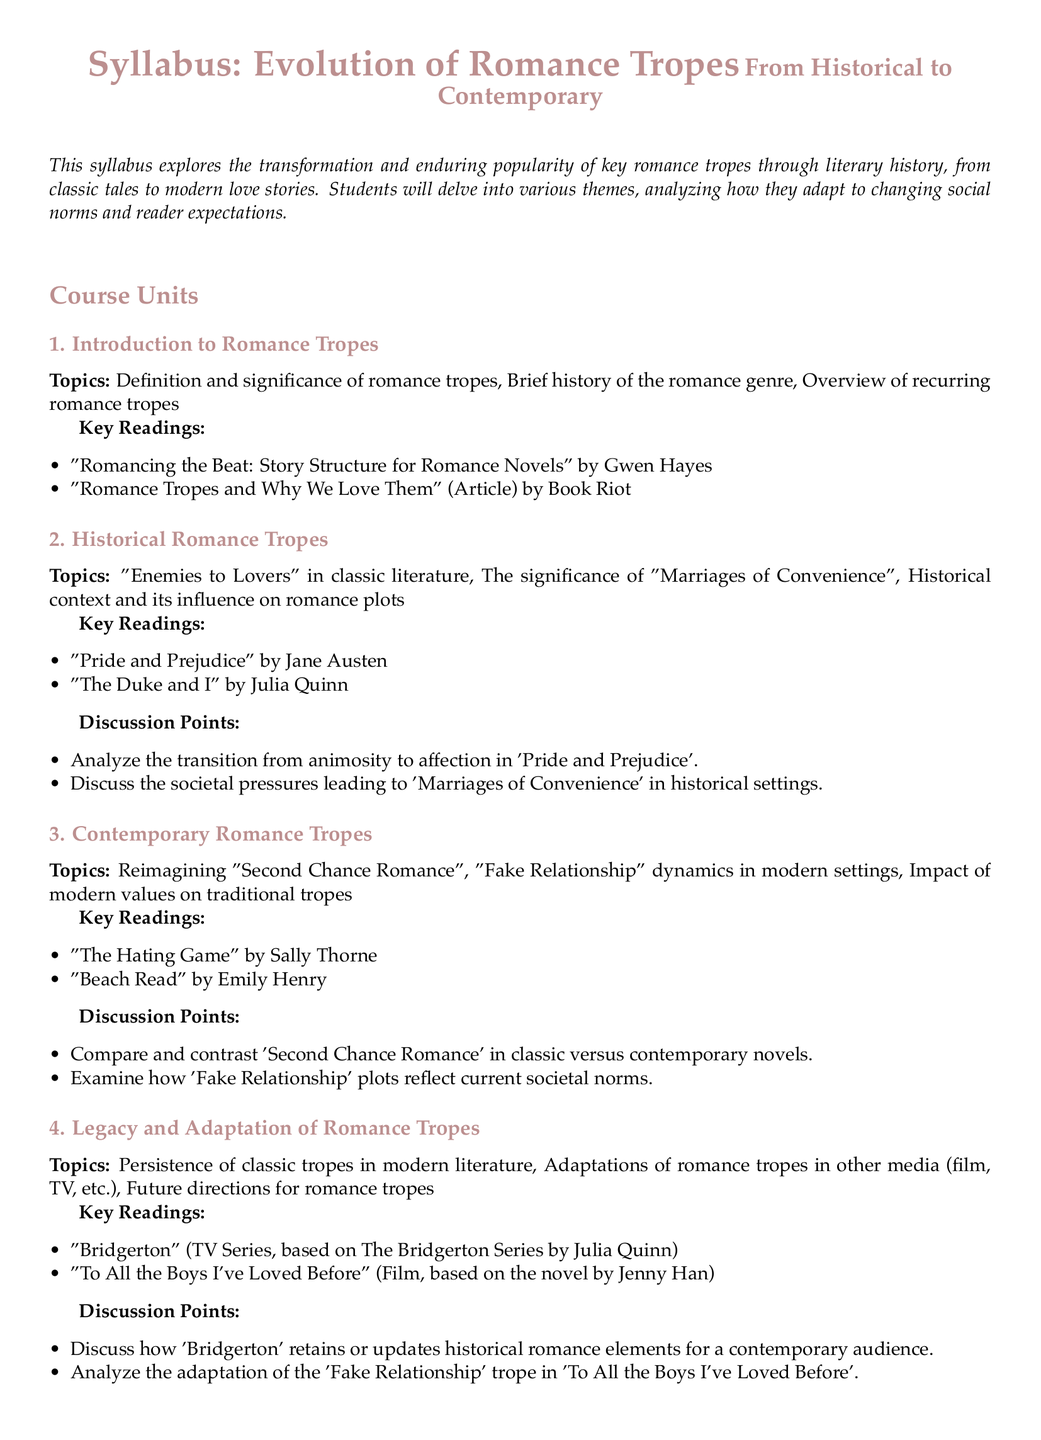What is the title of the syllabus? The title of the syllabus is in the document's header, representing the course's focus.
Answer: Evolution of Romance Tropes How many course units are in the syllabus? The document lists the course units structured under the content section, which totals four units.
Answer: 4 What is one key reading from the "Historical Romance Tropes" unit? The syllabus specifies key readings for each unit, and this particular unit includes a notable classic novel.
Answer: Pride and Prejudice What is the focus of the course? The introductory section summarizes the aim of the syllabus regarding romance tropes through time.
Answer: Transformation and enduring popularity Which modern novel is cited under "Contemporary Romance Tropes"? The syllabus lists contemporary readings that represent current romance trends, one of which is a popular modern novel.
Answer: Beach Read What is the final project type mentioned in the syllabus? The assessment methods section defines the structure of the final project, which is an essential component of the syllabus.
Answer: Comparative essay What is the theme of the "Legacy and Adaptation of Romance Tropes" unit? This unit's topic encapsulates the ongoing relevance and transformation of classic themes in current literature.
Answer: Persistence of classic tropes Who is the author of "Romancing the Beat"? The syllabus details key readings, including this title authored by a well-known figure in romance writing.
Answer: Gwen Hayes Which media adaptations of romance tropes are mentioned? The document highlights specific adaptations that effectively demonstrate the adaptation of romance themes in different formats.
Answer: Bridgerton and To All the Boys I've Loved Before 